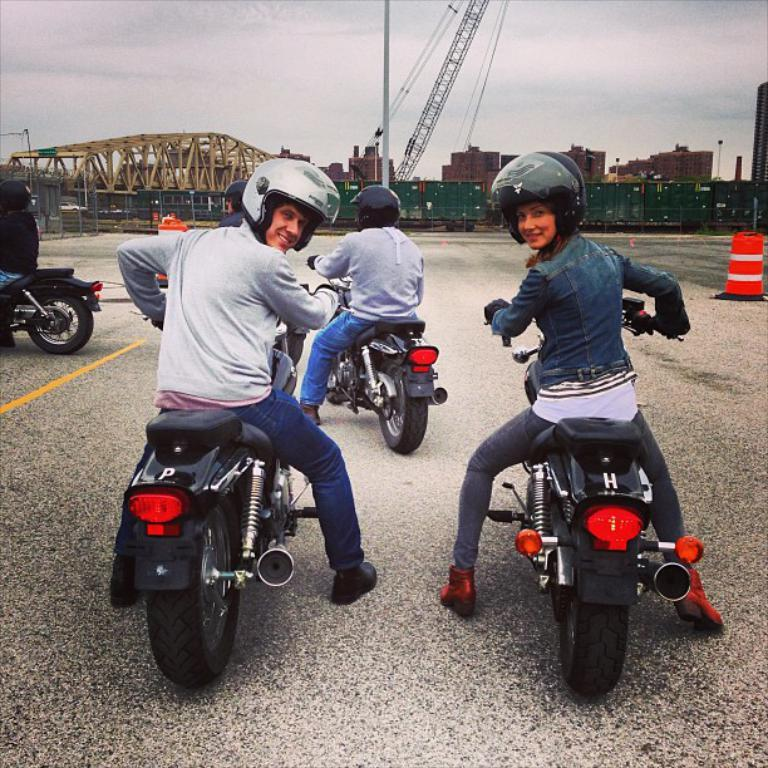What are the people in the image doing? The people in the image are sitting on bikes. What safety precaution are the people taking? The people are wearing helmets. What can be seen in the background of the image? There is a goods train, a crane, the sky, and pillars in the background. What type of steam is coming out of the orange in the image? There is no orange or steam present in the image. How many seeds can be seen in the image? There are no seeds visible in the image. 